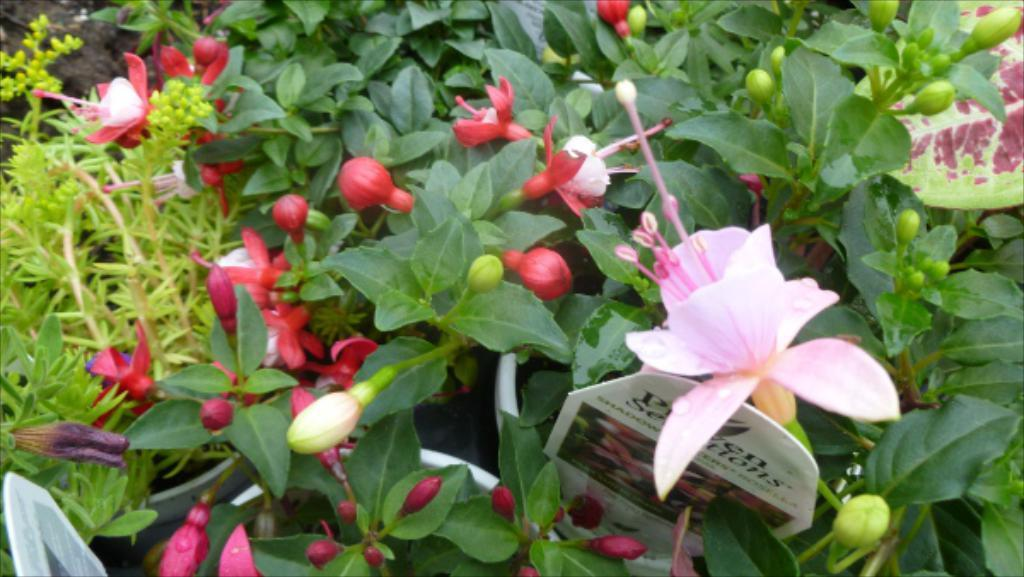What types of plants are visible in the image? There are plants with flowers, buds, and leaves in the image. How are the plants arranged or contained in the image? There are flower pots in the image, which suggests that the plants are arranged in pots. Can you describe the overall appearance of the image? The image resembles a card, which might indicate that it is a greeting card or a similar type of card. What type of lunch is being served in the image? There is no lunch present in the image; it features plants in flower pots and resembles a card. 